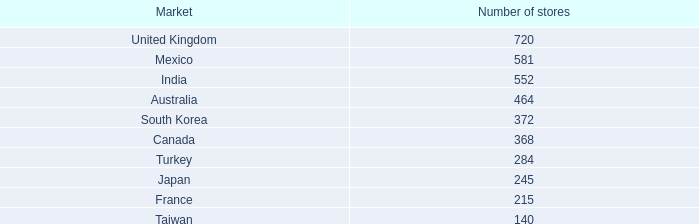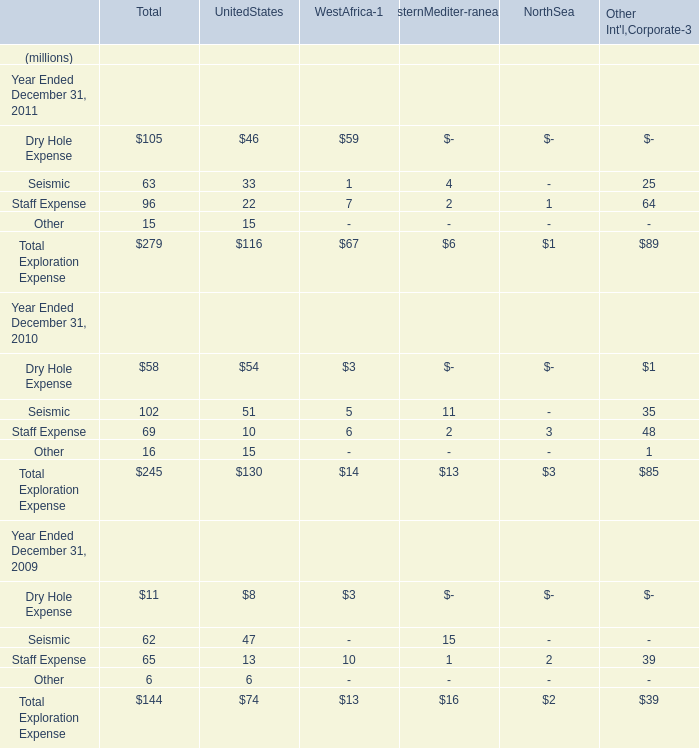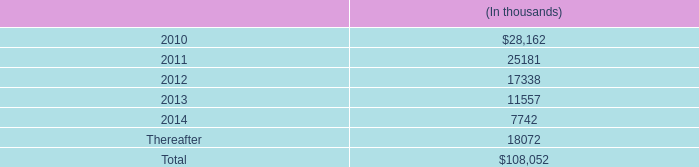Which year is Total Exploration Expense of Total greater than 260 million as Year is Ended December 31? 
Answer: 2011. 